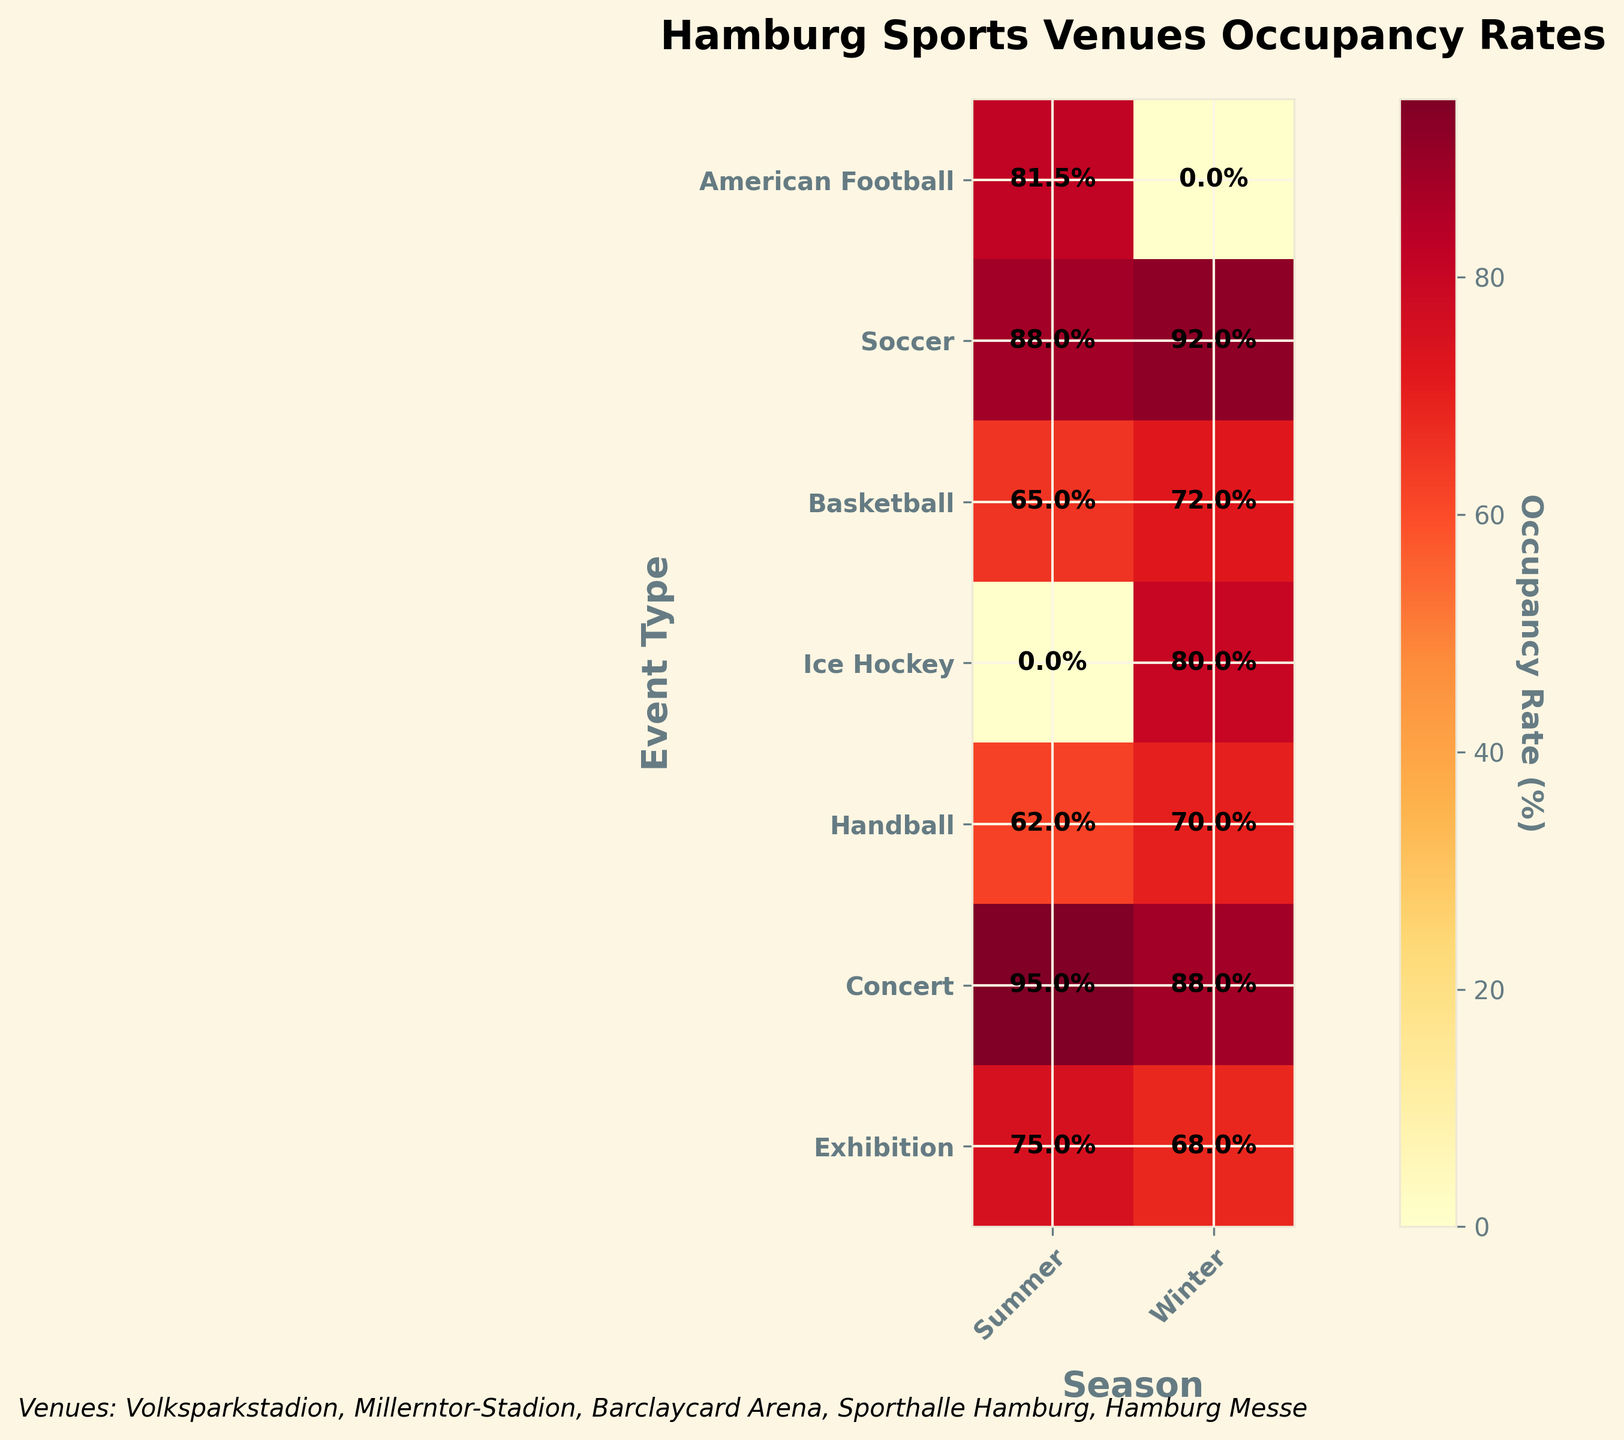What's the title of the mosaic plot? The title is usually located at the top of the plot and is intended to provide a summary of the visual representation. According to the code, it's set to be "Hamburg Sports Venues Occupancy Rates".
Answer: Hamburg Sports Venues Occupancy Rates Which season shows the highest occupancy rate for concerts? In the mosaic plot, the color intensity helps to determine occupancy rates, with higher percentages generally represented by more intense colors. Summer concerts at the Barclaycard Arena show an occupancy rate of 95%, which is higher than winter's 88%.
Answer: Summer What is the average occupancy rate for American Football events? From the mosaic plot, note the occupancy rates for American Football: 85% (Summer, Volksparkstadion) and 78% (Summer, Millerntor-Stadion). Calculate their average: (85 + 78) / 2 = 81.5%.
Answer: 81.5% Which event type has the highest variance in occupancy rates across seasons? Identify the occupancy rates for each event type and calculate the variance. Concerts have rates of 95% (Summer) and 88% (Winter), a difference of 7%. Compare this variance with other event types to confirm which has the highest variation.
Answer: Concerts In which season does Barclaycard Arena have the highest average occupancy rate? Calculate the average occupancy rates for Barclaycard Arena in each season. For Summer: (65% Basketball + 80% Ice Hockey + 95% Concert) / 3 = 80%. For Winter: (72% Basketball + 88% Concert) / 2 = 80%. So, both seasons have the same average.
Answer: Both Which venue has the lowest occupancy rate for Summer events? Identify and compare the occupancy rates for all venues during Summer. The lowest is Sporthalle Hamburg with 62% for Handball.
Answer: Sporthalle Hamburg Is there a significant difference between the summer and winter occupancy rates for exhibitions? Check the occupancy rates for exhibitions in each season: 75% for Summer and 68% for Winter. The difference is 7%.
Answer: Yes, 7% difference How do the winter occupancy rate for soccer and ice hockey compare? Compare the respective occupancy rates directly from the plot: Soccer is 92% (Volksparkstadion) for Winter, and Ice Hockey is 80% (Barclaycard Arena) for Winter.
Answer: Soccer has a higher occupancy rate Which event type and season combination results in the highest occupancy rate? Identify the highest percentage value in the mosaic plot. For concerts in Summer at Barclaycard Arena, the occupancy rate is 95%, which is the highest.
Answer: Concert, Summer 